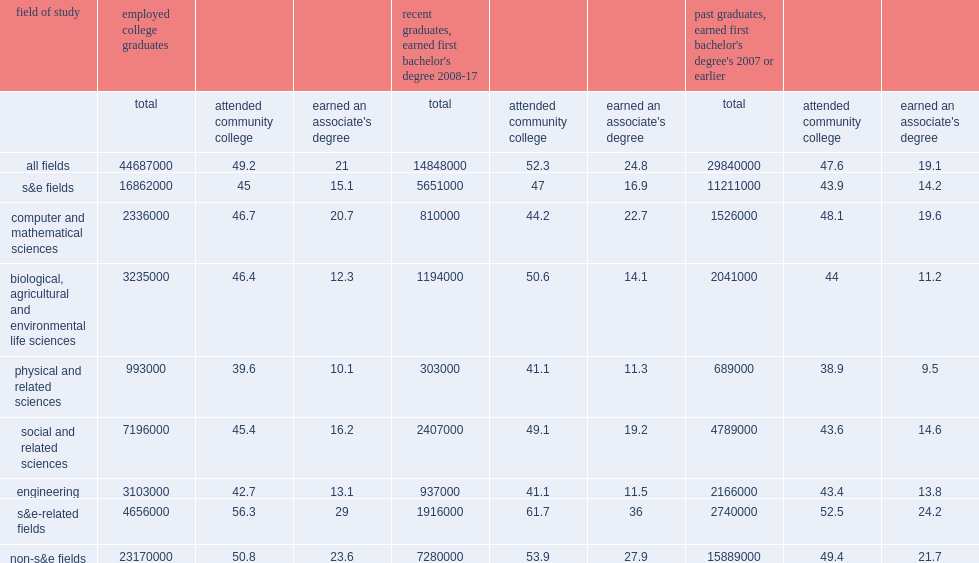Among all s&e majors, which study field's use of community colleges was lower, among those with degrees in engineering or s&e graduates? Engineering. Among all s&e majors, which study field's use of community colleges was lower, among those with degrees in the physical and related sciences or s&e graduates? Physical and related sciences. Help me parse the entirety of this table. {'header': ['field of study', 'employed college graduates', '', '', "recent graduates, earned first bachelor's degree 2008-17", '', '', "past graduates, earned first bachelor's degree's 2007 or earlier", '', ''], 'rows': [['', 'total', 'attended community college', "earned an associate's degree", 'total', 'attended community college', "earned an associate's degree", 'total', 'attended community college', "earned an associate's degree"], ['all fields', '44687000', '49.2', '21', '14848000', '52.3', '24.8', '29840000', '47.6', '19.1'], ['s&e fields', '16862000', '45', '15.1', '5651000', '47', '16.9', '11211000', '43.9', '14.2'], ['computer and mathematical sciences', '2336000', '46.7', '20.7', '810000', '44.2', '22.7', '1526000', '48.1', '19.6'], ['biological, agricultural and environmental life sciences', '3235000', '46.4', '12.3', '1194000', '50.6', '14.1', '2041000', '44', '11.2'], ['physical and related sciences', '993000', '39.6', '10.1', '303000', '41.1', '11.3', '689000', '38.9', '9.5'], ['social and related sciences', '7196000', '45.4', '16.2', '2407000', '49.1', '19.2', '4789000', '43.6', '14.6'], ['engineering', '3103000', '42.7', '13.1', '937000', '41.1', '11.5', '2166000', '43.4', '13.8'], ['s&e-related fields', '4656000', '56.3', '29', '1916000', '61.7', '36', '2740000', '52.5', '24.2'], ['non-s&e fields', '23170000', '50.8', '23.6', '7280000', '53.9', '27.9', '15889000', '49.4', '21.7']]} 